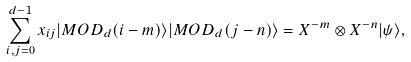Convert formula to latex. <formula><loc_0><loc_0><loc_500><loc_500>\sum _ { i , j = 0 } ^ { d - 1 } x _ { i j } | M O D _ { d } ( i - m ) \rangle | M O D _ { d } ( j - n ) \rangle = X ^ { - m } \otimes X ^ { - n } | \psi \rangle ,</formula> 